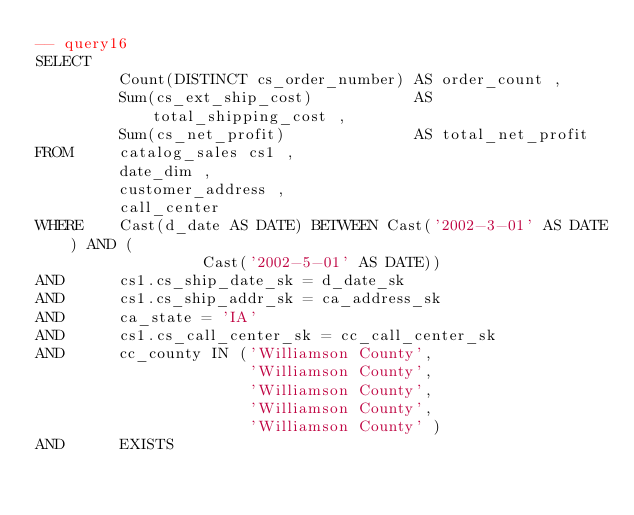Convert code to text. <code><loc_0><loc_0><loc_500><loc_500><_SQL_>-- query16
SELECT
         Count(DISTINCT cs_order_number) AS order_count ,
         Sum(cs_ext_ship_cost)           AS total_shipping_cost ,
         Sum(cs_net_profit)              AS total_net_profit
FROM     catalog_sales cs1 ,
         date_dim ,
         customer_address ,
         call_center
WHERE    Cast(d_date AS DATE) BETWEEN Cast('2002-3-01' AS DATE) AND (
                  Cast('2002-5-01' AS DATE))
AND      cs1.cs_ship_date_sk = d_date_sk
AND      cs1.cs_ship_addr_sk = ca_address_sk
AND      ca_state = 'IA'
AND      cs1.cs_call_center_sk = cc_call_center_sk
AND      cc_county IN ('Williamson County',
                       'Williamson County',
                       'Williamson County',
                       'Williamson County',
                       'Williamson County' )
AND      EXISTS</code> 